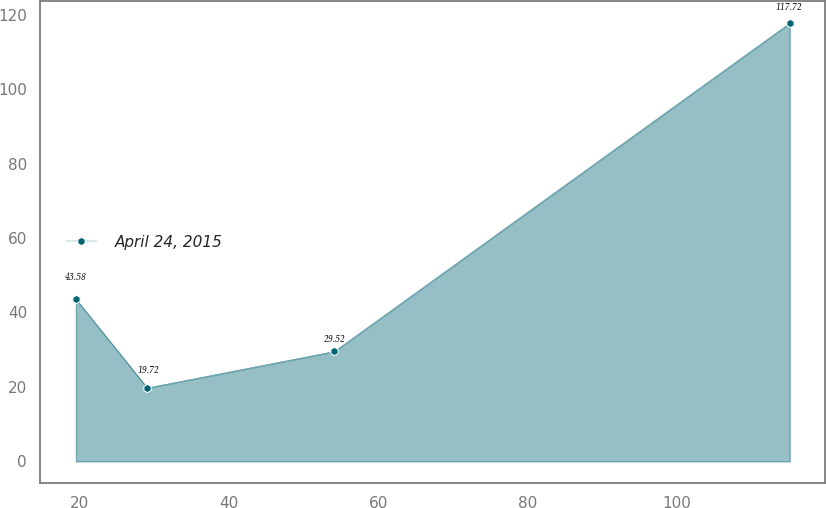Convert chart. <chart><loc_0><loc_0><loc_500><loc_500><line_chart><ecel><fcel>April 24, 2015<nl><fcel>19.51<fcel>43.58<nl><fcel>29.07<fcel>19.72<nl><fcel>54.1<fcel>29.52<nl><fcel>115.06<fcel>117.72<nl></chart> 